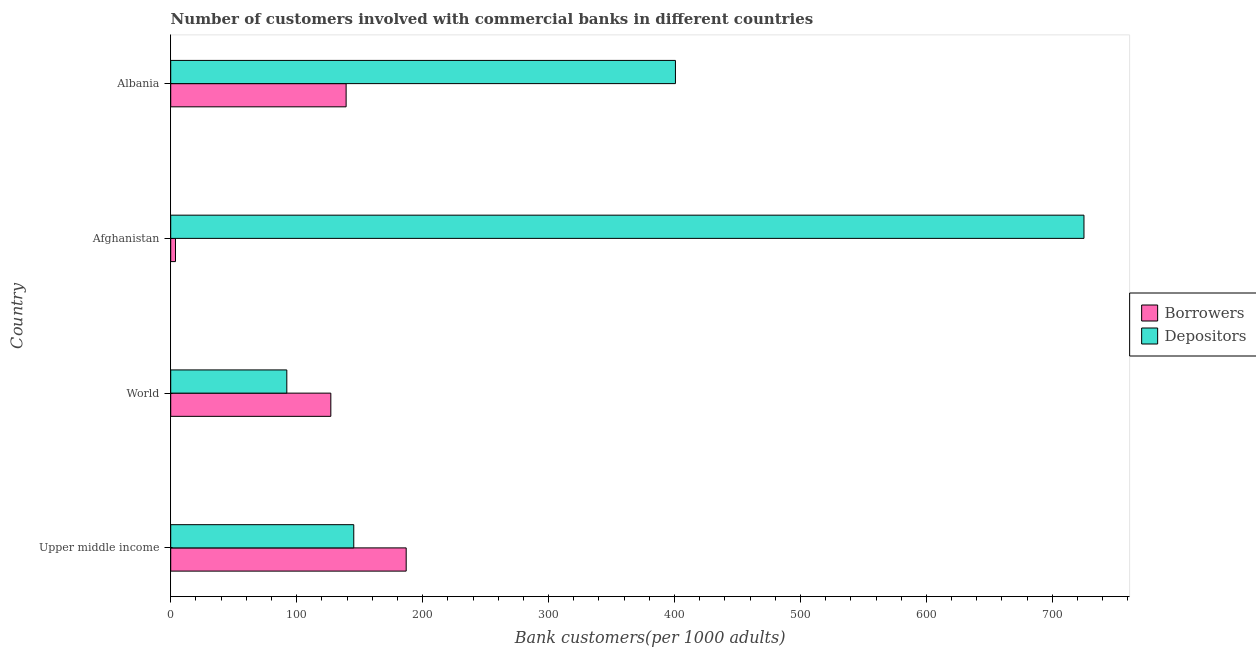How many different coloured bars are there?
Keep it short and to the point. 2. Are the number of bars on each tick of the Y-axis equal?
Your answer should be compact. Yes. How many bars are there on the 1st tick from the bottom?
Offer a very short reply. 2. What is the number of depositors in Afghanistan?
Provide a short and direct response. 725.1. Across all countries, what is the maximum number of depositors?
Keep it short and to the point. 725.1. Across all countries, what is the minimum number of depositors?
Your answer should be compact. 92.17. In which country was the number of borrowers maximum?
Make the answer very short. Upper middle income. In which country was the number of borrowers minimum?
Your response must be concise. Afghanistan. What is the total number of depositors in the graph?
Your answer should be compact. 1363.34. What is the difference between the number of borrowers in Afghanistan and that in Upper middle income?
Offer a very short reply. -183.16. What is the difference between the number of borrowers in Albania and the number of depositors in Afghanistan?
Your response must be concise. -585.84. What is the average number of borrowers per country?
Offer a terse response. 114.29. What is the difference between the number of borrowers and number of depositors in Albania?
Keep it short and to the point. -261.46. In how many countries, is the number of borrowers greater than 240 ?
Offer a terse response. 0. What is the ratio of the number of depositors in Upper middle income to that in World?
Your response must be concise. 1.58. Is the number of depositors in Upper middle income less than that in World?
Give a very brief answer. No. Is the difference between the number of borrowers in Upper middle income and World greater than the difference between the number of depositors in Upper middle income and World?
Your response must be concise. Yes. What is the difference between the highest and the second highest number of depositors?
Make the answer very short. 324.37. What is the difference between the highest and the lowest number of depositors?
Offer a very short reply. 632.93. Is the sum of the number of depositors in Afghanistan and Albania greater than the maximum number of borrowers across all countries?
Offer a terse response. Yes. What does the 1st bar from the top in Upper middle income represents?
Offer a terse response. Depositors. What does the 2nd bar from the bottom in Afghanistan represents?
Provide a succinct answer. Depositors. How many bars are there?
Provide a succinct answer. 8. Are all the bars in the graph horizontal?
Make the answer very short. Yes. How many countries are there in the graph?
Provide a short and direct response. 4. What is the difference between two consecutive major ticks on the X-axis?
Provide a short and direct response. 100. Are the values on the major ticks of X-axis written in scientific E-notation?
Your answer should be very brief. No. Does the graph contain any zero values?
Your answer should be compact. No. What is the title of the graph?
Your response must be concise. Number of customers involved with commercial banks in different countries. Does "Highest 20% of population" appear as one of the legend labels in the graph?
Provide a succinct answer. No. What is the label or title of the X-axis?
Ensure brevity in your answer.  Bank customers(per 1000 adults). What is the label or title of the Y-axis?
Provide a short and direct response. Country. What is the Bank customers(per 1000 adults) in Borrowers in Upper middle income?
Your answer should be compact. 186.95. What is the Bank customers(per 1000 adults) of Depositors in Upper middle income?
Provide a succinct answer. 145.33. What is the Bank customers(per 1000 adults) in Borrowers in World?
Keep it short and to the point. 127.13. What is the Bank customers(per 1000 adults) of Depositors in World?
Provide a succinct answer. 92.17. What is the Bank customers(per 1000 adults) in Borrowers in Afghanistan?
Offer a terse response. 3.79. What is the Bank customers(per 1000 adults) in Depositors in Afghanistan?
Your response must be concise. 725.1. What is the Bank customers(per 1000 adults) of Borrowers in Albania?
Provide a short and direct response. 139.27. What is the Bank customers(per 1000 adults) of Depositors in Albania?
Ensure brevity in your answer.  400.73. Across all countries, what is the maximum Bank customers(per 1000 adults) in Borrowers?
Give a very brief answer. 186.95. Across all countries, what is the maximum Bank customers(per 1000 adults) in Depositors?
Provide a succinct answer. 725.1. Across all countries, what is the minimum Bank customers(per 1000 adults) of Borrowers?
Provide a short and direct response. 3.79. Across all countries, what is the minimum Bank customers(per 1000 adults) in Depositors?
Offer a terse response. 92.17. What is the total Bank customers(per 1000 adults) of Borrowers in the graph?
Keep it short and to the point. 457.15. What is the total Bank customers(per 1000 adults) of Depositors in the graph?
Your response must be concise. 1363.34. What is the difference between the Bank customers(per 1000 adults) of Borrowers in Upper middle income and that in World?
Give a very brief answer. 59.83. What is the difference between the Bank customers(per 1000 adults) in Depositors in Upper middle income and that in World?
Give a very brief answer. 53.16. What is the difference between the Bank customers(per 1000 adults) in Borrowers in Upper middle income and that in Afghanistan?
Your response must be concise. 183.16. What is the difference between the Bank customers(per 1000 adults) in Depositors in Upper middle income and that in Afghanistan?
Provide a short and direct response. -579.77. What is the difference between the Bank customers(per 1000 adults) in Borrowers in Upper middle income and that in Albania?
Offer a terse response. 47.69. What is the difference between the Bank customers(per 1000 adults) of Depositors in Upper middle income and that in Albania?
Offer a very short reply. -255.4. What is the difference between the Bank customers(per 1000 adults) in Borrowers in World and that in Afghanistan?
Your answer should be very brief. 123.33. What is the difference between the Bank customers(per 1000 adults) in Depositors in World and that in Afghanistan?
Your answer should be compact. -632.93. What is the difference between the Bank customers(per 1000 adults) in Borrowers in World and that in Albania?
Keep it short and to the point. -12.14. What is the difference between the Bank customers(per 1000 adults) of Depositors in World and that in Albania?
Offer a terse response. -308.56. What is the difference between the Bank customers(per 1000 adults) in Borrowers in Afghanistan and that in Albania?
Provide a short and direct response. -135.47. What is the difference between the Bank customers(per 1000 adults) in Depositors in Afghanistan and that in Albania?
Your answer should be compact. 324.37. What is the difference between the Bank customers(per 1000 adults) in Borrowers in Upper middle income and the Bank customers(per 1000 adults) in Depositors in World?
Ensure brevity in your answer.  94.78. What is the difference between the Bank customers(per 1000 adults) of Borrowers in Upper middle income and the Bank customers(per 1000 adults) of Depositors in Afghanistan?
Your response must be concise. -538.15. What is the difference between the Bank customers(per 1000 adults) of Borrowers in Upper middle income and the Bank customers(per 1000 adults) of Depositors in Albania?
Your answer should be compact. -213.78. What is the difference between the Bank customers(per 1000 adults) of Borrowers in World and the Bank customers(per 1000 adults) of Depositors in Afghanistan?
Keep it short and to the point. -597.97. What is the difference between the Bank customers(per 1000 adults) of Borrowers in World and the Bank customers(per 1000 adults) of Depositors in Albania?
Keep it short and to the point. -273.6. What is the difference between the Bank customers(per 1000 adults) of Borrowers in Afghanistan and the Bank customers(per 1000 adults) of Depositors in Albania?
Your answer should be compact. -396.94. What is the average Bank customers(per 1000 adults) of Borrowers per country?
Provide a short and direct response. 114.29. What is the average Bank customers(per 1000 adults) in Depositors per country?
Offer a terse response. 340.83. What is the difference between the Bank customers(per 1000 adults) in Borrowers and Bank customers(per 1000 adults) in Depositors in Upper middle income?
Keep it short and to the point. 41.62. What is the difference between the Bank customers(per 1000 adults) of Borrowers and Bank customers(per 1000 adults) of Depositors in World?
Your response must be concise. 34.95. What is the difference between the Bank customers(per 1000 adults) of Borrowers and Bank customers(per 1000 adults) of Depositors in Afghanistan?
Offer a terse response. -721.31. What is the difference between the Bank customers(per 1000 adults) of Borrowers and Bank customers(per 1000 adults) of Depositors in Albania?
Your answer should be compact. -261.46. What is the ratio of the Bank customers(per 1000 adults) in Borrowers in Upper middle income to that in World?
Offer a very short reply. 1.47. What is the ratio of the Bank customers(per 1000 adults) in Depositors in Upper middle income to that in World?
Your response must be concise. 1.58. What is the ratio of the Bank customers(per 1000 adults) of Borrowers in Upper middle income to that in Afghanistan?
Make the answer very short. 49.27. What is the ratio of the Bank customers(per 1000 adults) of Depositors in Upper middle income to that in Afghanistan?
Ensure brevity in your answer.  0.2. What is the ratio of the Bank customers(per 1000 adults) in Borrowers in Upper middle income to that in Albania?
Ensure brevity in your answer.  1.34. What is the ratio of the Bank customers(per 1000 adults) in Depositors in Upper middle income to that in Albania?
Keep it short and to the point. 0.36. What is the ratio of the Bank customers(per 1000 adults) in Borrowers in World to that in Afghanistan?
Ensure brevity in your answer.  33.5. What is the ratio of the Bank customers(per 1000 adults) in Depositors in World to that in Afghanistan?
Keep it short and to the point. 0.13. What is the ratio of the Bank customers(per 1000 adults) in Borrowers in World to that in Albania?
Make the answer very short. 0.91. What is the ratio of the Bank customers(per 1000 adults) of Depositors in World to that in Albania?
Keep it short and to the point. 0.23. What is the ratio of the Bank customers(per 1000 adults) of Borrowers in Afghanistan to that in Albania?
Offer a very short reply. 0.03. What is the ratio of the Bank customers(per 1000 adults) of Depositors in Afghanistan to that in Albania?
Give a very brief answer. 1.81. What is the difference between the highest and the second highest Bank customers(per 1000 adults) in Borrowers?
Give a very brief answer. 47.69. What is the difference between the highest and the second highest Bank customers(per 1000 adults) of Depositors?
Provide a succinct answer. 324.37. What is the difference between the highest and the lowest Bank customers(per 1000 adults) of Borrowers?
Give a very brief answer. 183.16. What is the difference between the highest and the lowest Bank customers(per 1000 adults) of Depositors?
Provide a succinct answer. 632.93. 